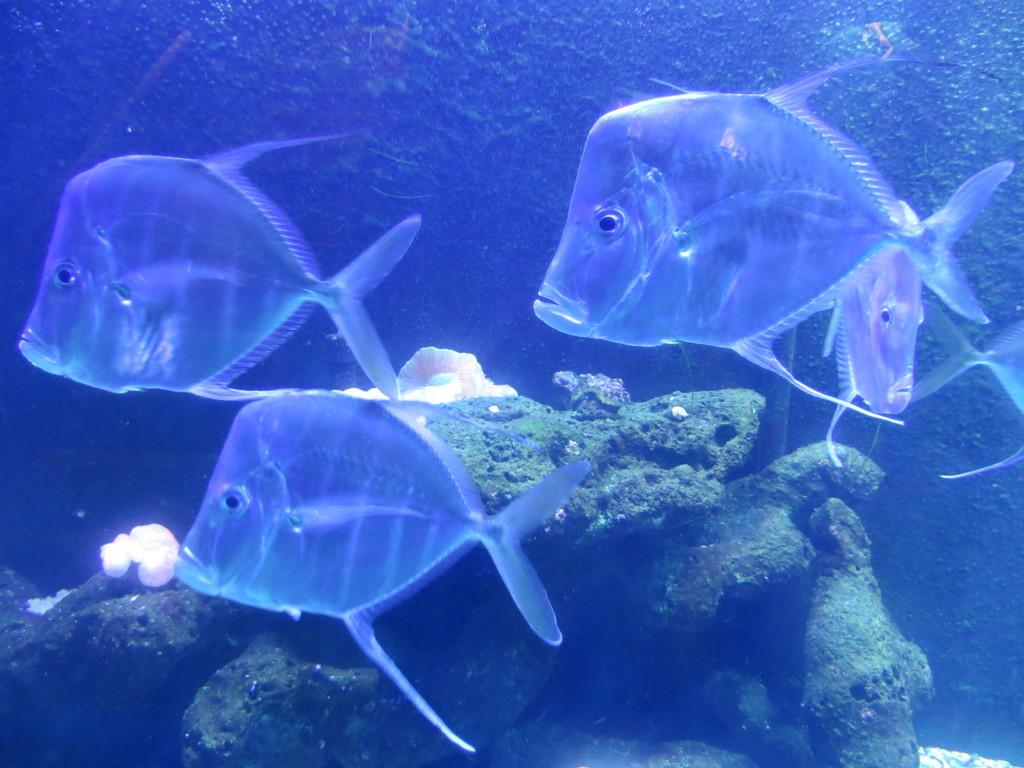How many fishes can be seen in the image? There are four fishes in the image. What type of fishes are present in the image? The fishes are submarine species. Where might this image have been taken? The image may have been taken in the ocean. What type of plants can be seen growing on the tramp in the image? There is no tramp or plants present in the image; it features four fishes in a marine environment. 